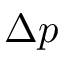<formula> <loc_0><loc_0><loc_500><loc_500>\Delta p</formula> 